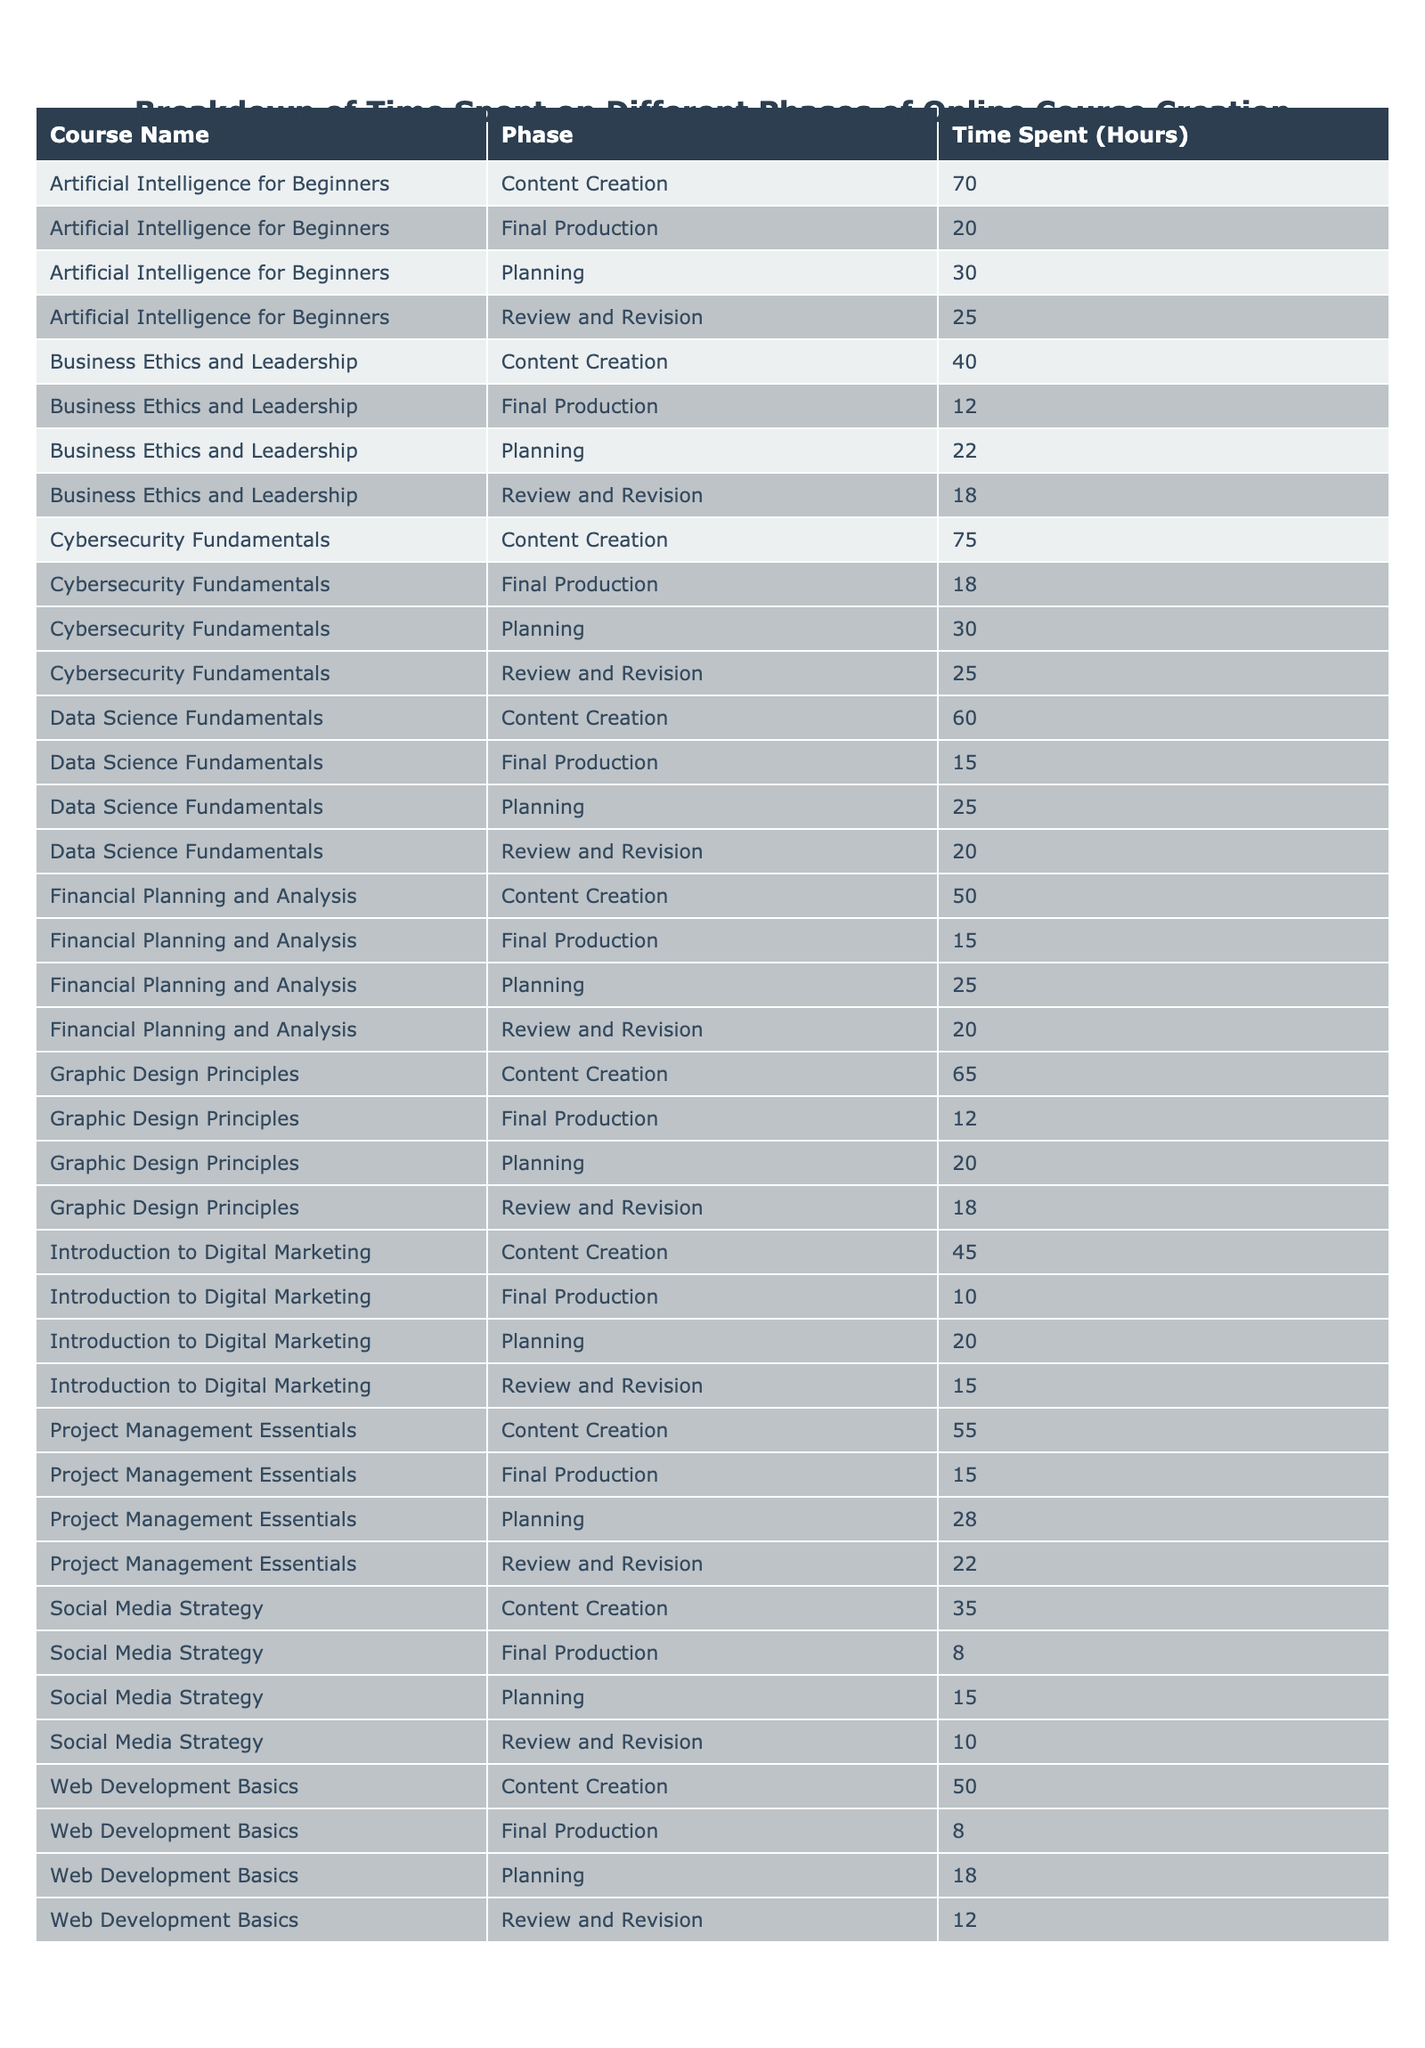What is the time spent on the content creation phase for the course "Data Science Fundamentals"? From the table, locate the row for "Data Science Fundamentals" under the "Content Creation" phase. It shows a value of 60 hours.
Answer: 60 hours What was the total time spent on the planning phase across all courses? To find the total time spent on the planning phase, add the hours for each planning phase: 20 + 25 + 18 + 22 + 30 + 15 + 28 + 20 + 25 + 30 =  243 hours.
Answer: 243 hours Did any course take more than 75 hours in the content creation phase? By inspecting the table, we see that "Cybersecurity Fundamentals" took 75 hours, which is equal to 75, and no course exceeded that hour.
Answer: No Which course had the highest time spent in the review and revision phase? Look through the "Review and Revision" values in the table and identify the maximum value. The highest is for "Artificial Intelligence for Beginners" with 25 hours.
Answer: Artificial Intelligence for Beginners What is the average time spent on final production across all courses? To find the average, first sum the hours for final production: 10 + 15 + 8 + 12 + 20 + 8 + 15 + 12 + 15 + 18 =  138. Then divide by the number of courses, which is 10: 138 / 10 = 13.8 hours.
Answer: 13.8 hours For which course was the content creation time shorter than the review and revision time? Review the content creation and review and revision times for each course. None of the courses have content creation time shorter than review and revision, which means all courses have content creation longer.
Answer: None What is the difference in time spent on content creation between "Web Development Basics" and "Graphic Design Principles"? Subtract the content creation time of "Graphic Design Principles" (65 hours) from "Web Development Basics" (50 hours): 65 - 50 = 15 hours.
Answer: 15 hours How many courses had a planning phase that took more than 25 hours? Inspect the planning phase times: 20, 25, 18, 22, 30, 15, 28, 20, 25, 30. The courses with over 25 hours are "Artificial Intelligence for Beginners," "Project Management Essentials," and "Cybersecurity Fundamentals," resulting in a count of 3.
Answer: 3 courses What phase took the least amount of time on the course "Business Ethics and Leadership"? Looking through the phases for "Business Ethics and Leadership," the final production phase took 12 hours, which is the least compared to the other phases.
Answer: Final Production Which two courses had the closest total hours spent on all phases? Calculate the total hours for each course, then compare them. After calculation, "Financial Planning and Analysis" (110 hours) and "Business Ethics and Leadership" (92 hours) had the least difference of 18 hours.
Answer: Financial Planning and Analysis and Business Ethics and Leadership 